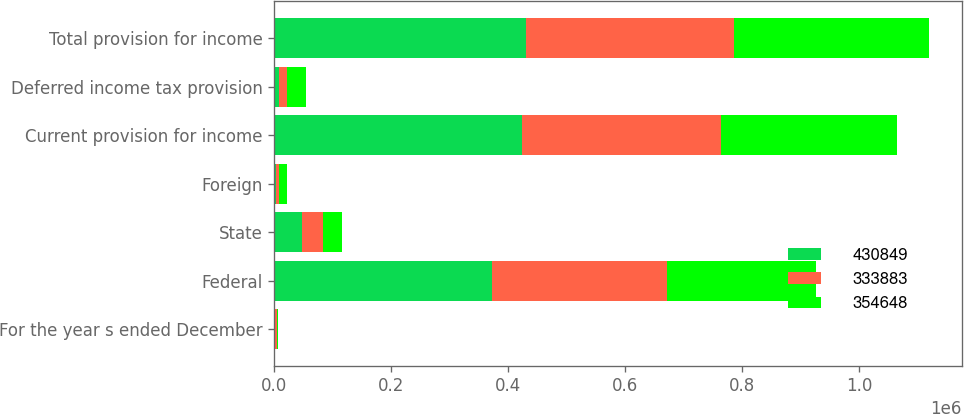Convert chart to OTSL. <chart><loc_0><loc_0><loc_500><loc_500><stacked_bar_chart><ecel><fcel>For the year s ended December<fcel>Federal<fcel>State<fcel>Foreign<fcel>Current provision for income<fcel>Deferred income tax provision<fcel>Total provision for income<nl><fcel>430849<fcel>2013<fcel>372649<fcel>47980<fcel>2763<fcel>423392<fcel>7457<fcel>430849<nl><fcel>333883<fcel>2012<fcel>299122<fcel>36187<fcel>5554<fcel>340863<fcel>13785<fcel>354648<nl><fcel>354648<fcel>2011<fcel>254732<fcel>32174<fcel>13366<fcel>300272<fcel>33611<fcel>333883<nl></chart> 